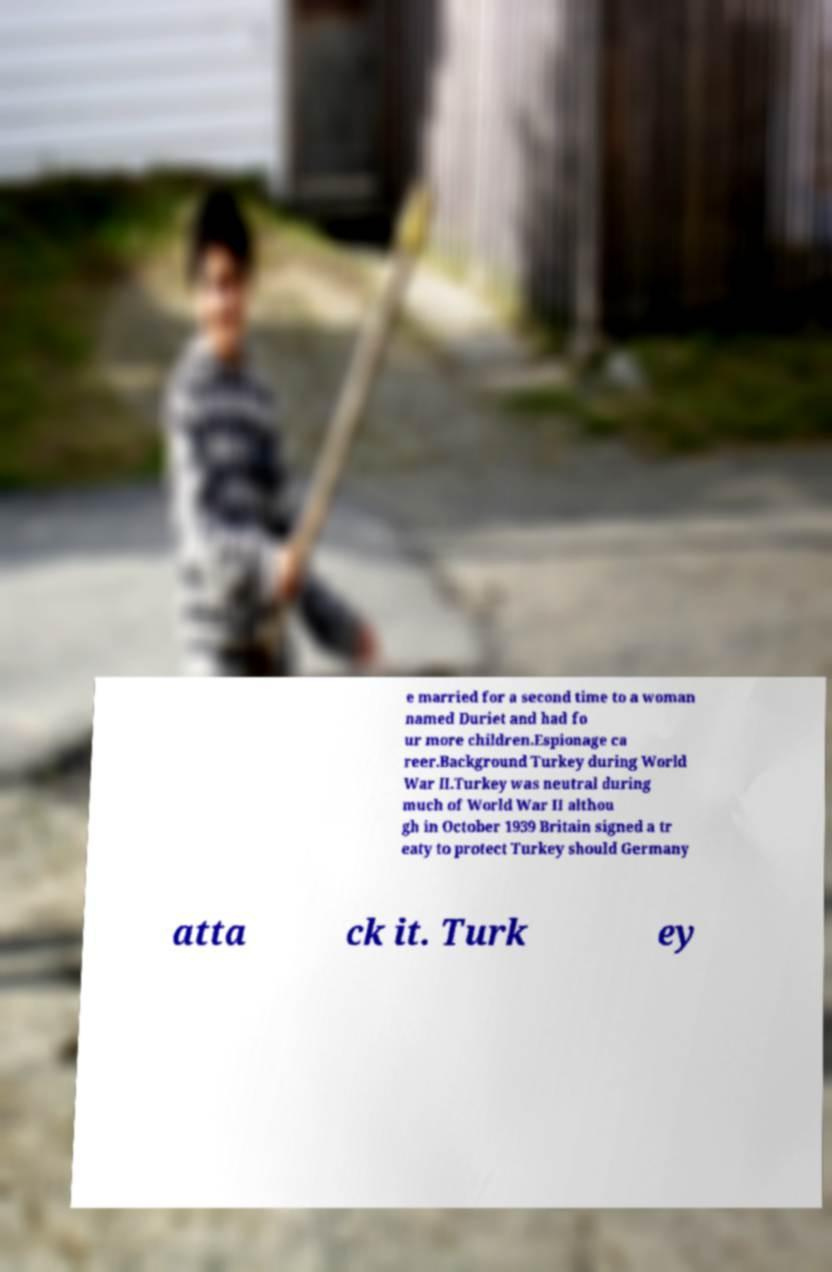What messages or text are displayed in this image? I need them in a readable, typed format. e married for a second time to a woman named Duriet and had fo ur more children.Espionage ca reer.Background Turkey during World War II.Turkey was neutral during much of World War II althou gh in October 1939 Britain signed a tr eaty to protect Turkey should Germany atta ck it. Turk ey 